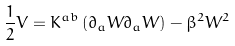<formula> <loc_0><loc_0><loc_500><loc_500>\frac { 1 } { 2 } V = K ^ { a b } \left ( \partial _ { a } W \partial _ { a } W \right ) - \beta ^ { 2 } W ^ { 2 }</formula> 